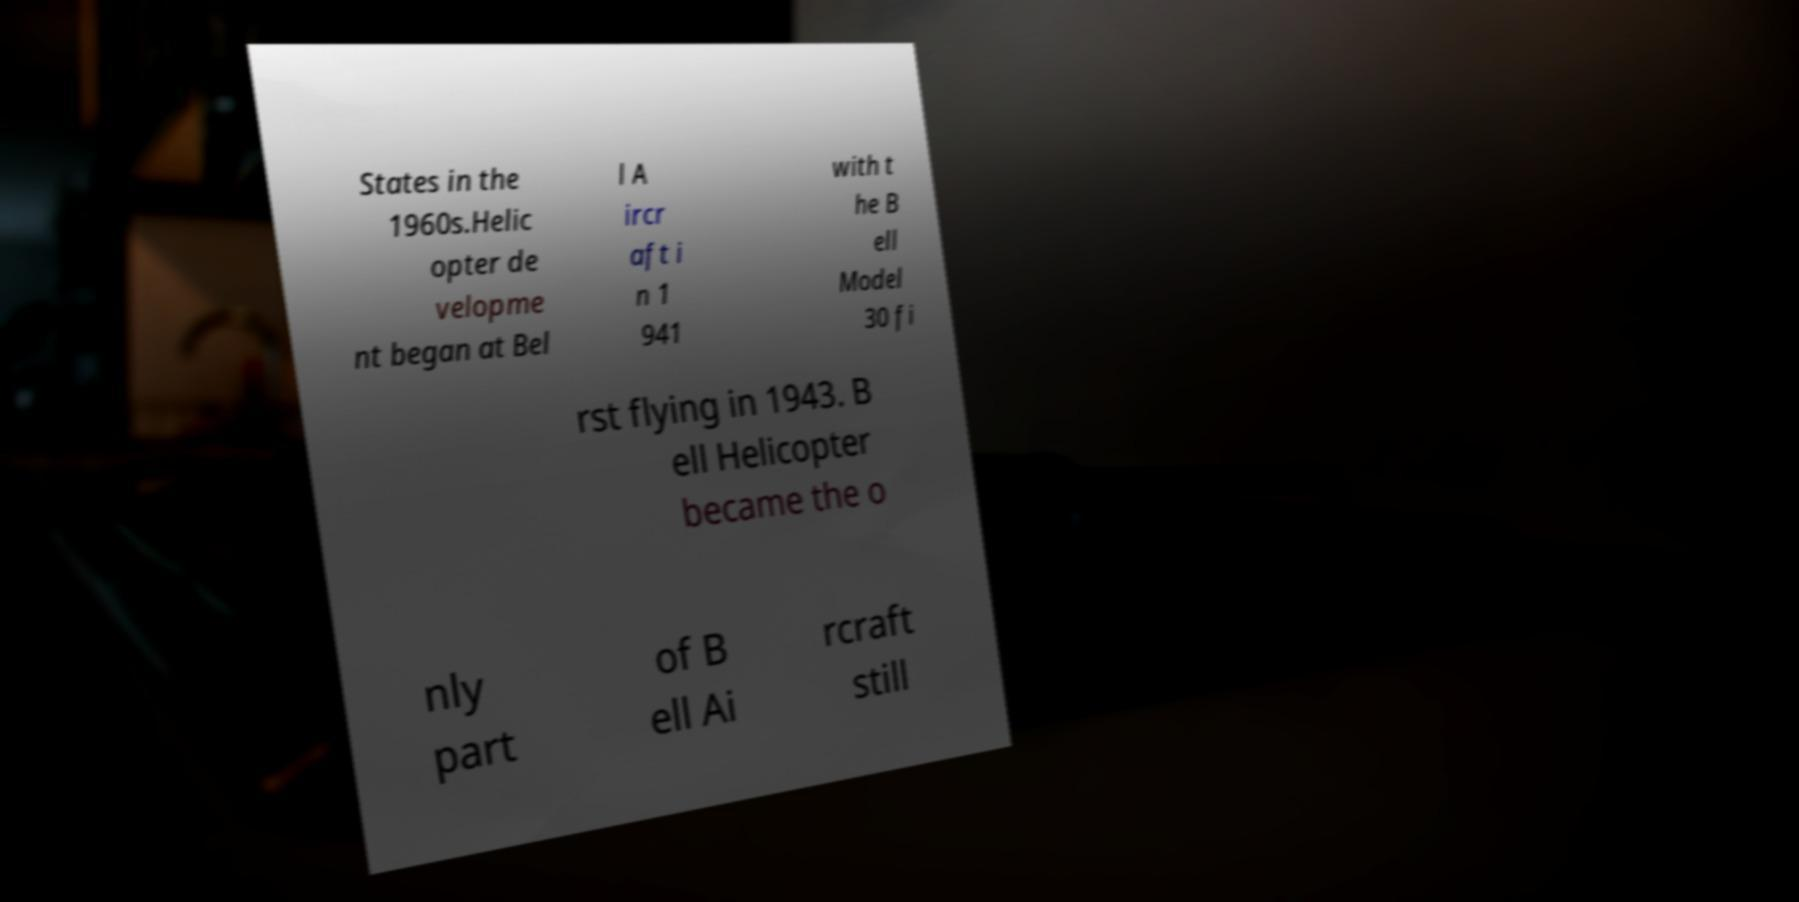I need the written content from this picture converted into text. Can you do that? States in the 1960s.Helic opter de velopme nt began at Bel l A ircr aft i n 1 941 with t he B ell Model 30 fi rst flying in 1943. B ell Helicopter became the o nly part of B ell Ai rcraft still 